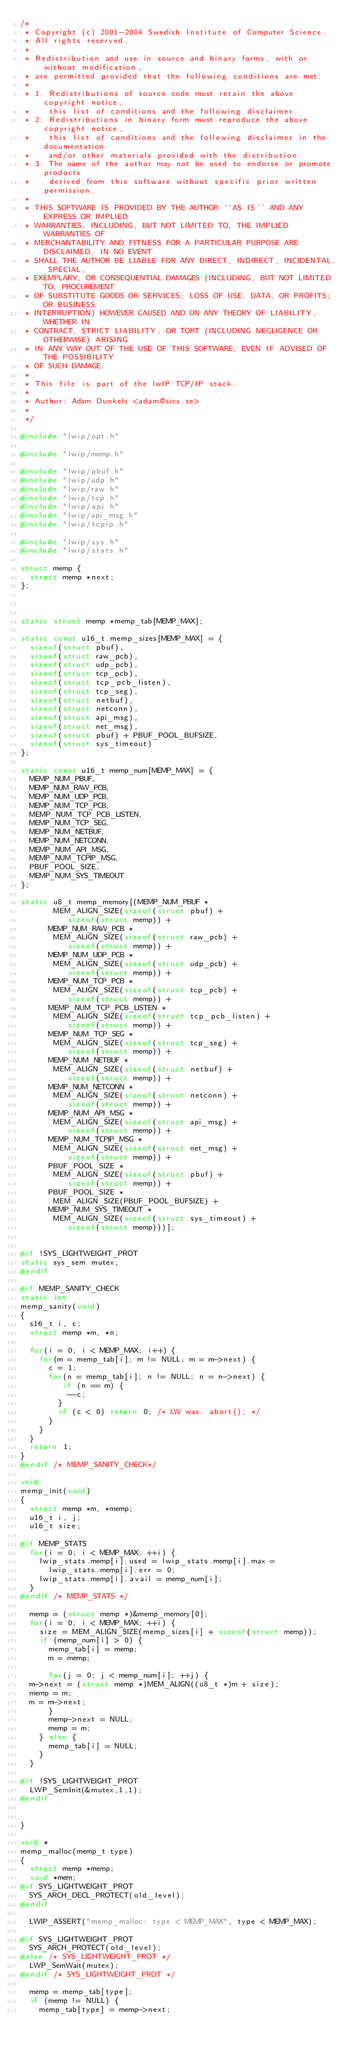Convert code to text. <code><loc_0><loc_0><loc_500><loc_500><_C_>/*
 * Copyright (c) 2001-2004 Swedish Institute of Computer Science.
 * All rights reserved. 
 * 
 * Redistribution and use in source and binary forms, with or without modification, 
 * are permitted provided that the following conditions are met:
 *
 * 1. Redistributions of source code must retain the above copyright notice,
 *    this list of conditions and the following disclaimer.
 * 2. Redistributions in binary form must reproduce the above copyright notice,
 *    this list of conditions and the following disclaimer in the documentation
 *    and/or other materials provided with the distribution.
 * 3. The name of the author may not be used to endorse or promote products
 *    derived from this software without specific prior written permission. 
 *
 * THIS SOFTWARE IS PROVIDED BY THE AUTHOR ``AS IS'' AND ANY EXPRESS OR IMPLIED 
 * WARRANTIES, INCLUDING, BUT NOT LIMITED TO, THE IMPLIED WARRANTIES OF 
 * MERCHANTABILITY AND FITNESS FOR A PARTICULAR PURPOSE ARE DISCLAIMED. IN NO EVENT 
 * SHALL THE AUTHOR BE LIABLE FOR ANY DIRECT, INDIRECT, INCIDENTAL, SPECIAL, 
 * EXEMPLARY, OR CONSEQUENTIAL DAMAGES (INCLUDING, BUT NOT LIMITED TO, PROCUREMENT 
 * OF SUBSTITUTE GOODS OR SERVICES; LOSS OF USE, DATA, OR PROFITS; OR BUSINESS 
 * INTERRUPTION) HOWEVER CAUSED AND ON ANY THEORY OF LIABILITY, WHETHER IN 
 * CONTRACT, STRICT LIABILITY, OR TORT (INCLUDING NEGLIGENCE OR OTHERWISE) ARISING 
 * IN ANY WAY OUT OF THE USE OF THIS SOFTWARE, EVEN IF ADVISED OF THE POSSIBILITY 
 * OF SUCH DAMAGE.
 *
 * This file is part of the lwIP TCP/IP stack.
 * 
 * Author: Adam Dunkels <adam@sics.se>
 *
 */

#include "lwip/opt.h"

#include "lwip/memp.h"

#include "lwip/pbuf.h"
#include "lwip/udp.h"
#include "lwip/raw.h"
#include "lwip/tcp.h"
#include "lwip/api.h"
#include "lwip/api_msg.h"
#include "lwip/tcpip.h"

#include "lwip/sys.h"
#include "lwip/stats.h"

struct memp {
  struct memp *next;
};



static struct memp *memp_tab[MEMP_MAX];

static const u16_t memp_sizes[MEMP_MAX] = {
  sizeof(struct pbuf),
  sizeof(struct raw_pcb),
  sizeof(struct udp_pcb),
  sizeof(struct tcp_pcb),
  sizeof(struct tcp_pcb_listen),
  sizeof(struct tcp_seg),
  sizeof(struct netbuf),
  sizeof(struct netconn),
  sizeof(struct api_msg),
  sizeof(struct net_msg),
  sizeof(struct pbuf) + PBUF_POOL_BUFSIZE,
  sizeof(struct sys_timeout)
};

static const u16_t memp_num[MEMP_MAX] = {
  MEMP_NUM_PBUF,
  MEMP_NUM_RAW_PCB,
  MEMP_NUM_UDP_PCB,
  MEMP_NUM_TCP_PCB,
  MEMP_NUM_TCP_PCB_LISTEN,
  MEMP_NUM_TCP_SEG,
  MEMP_NUM_NETBUF,
  MEMP_NUM_NETCONN,
  MEMP_NUM_API_MSG,
  MEMP_NUM_TCPIP_MSG,
  PBUF_POOL_SIZE,
  MEMP_NUM_SYS_TIMEOUT
};

static u8_t memp_memory[(MEMP_NUM_PBUF *
       MEM_ALIGN_SIZE(sizeof(struct pbuf) +
          sizeof(struct memp)) +
      MEMP_NUM_RAW_PCB *
       MEM_ALIGN_SIZE(sizeof(struct raw_pcb) +
          sizeof(struct memp)) +
      MEMP_NUM_UDP_PCB *
       MEM_ALIGN_SIZE(sizeof(struct udp_pcb) +
          sizeof(struct memp)) +
      MEMP_NUM_TCP_PCB *
       MEM_ALIGN_SIZE(sizeof(struct tcp_pcb) +
          sizeof(struct memp)) +
      MEMP_NUM_TCP_PCB_LISTEN *
       MEM_ALIGN_SIZE(sizeof(struct tcp_pcb_listen) +
          sizeof(struct memp)) +
      MEMP_NUM_TCP_SEG *
       MEM_ALIGN_SIZE(sizeof(struct tcp_seg) +
          sizeof(struct memp)) +
      MEMP_NUM_NETBUF *
       MEM_ALIGN_SIZE(sizeof(struct netbuf) +
          sizeof(struct memp)) +
      MEMP_NUM_NETCONN *
       MEM_ALIGN_SIZE(sizeof(struct netconn) +
          sizeof(struct memp)) +
      MEMP_NUM_API_MSG *
       MEM_ALIGN_SIZE(sizeof(struct api_msg) +
          sizeof(struct memp)) +
      MEMP_NUM_TCPIP_MSG *
       MEM_ALIGN_SIZE(sizeof(struct net_msg) +
          sizeof(struct memp)) +
      PBUF_POOL_SIZE *
       MEM_ALIGN_SIZE(sizeof(struct pbuf) +
          sizeof(struct memp)) +
      PBUF_POOL_SIZE *
       MEM_ALIGN_SIZE(PBUF_POOL_BUFSIZE) +
      MEMP_NUM_SYS_TIMEOUT *
       MEM_ALIGN_SIZE(sizeof(struct sys_timeout) +
          sizeof(struct memp)))];


#if !SYS_LIGHTWEIGHT_PROT
static sys_sem mutex;
#endif

#if MEMP_SANITY_CHECK
static int
memp_sanity(void)
{
  s16_t i, c;
  struct memp *m, *n;

  for(i = 0; i < MEMP_MAX; i++) {
    for(m = memp_tab[i]; m != NULL; m = m->next) {
      c = 1;
      for(n = memp_tab[i]; n != NULL; n = n->next) {
         if (n == m) {
          --c;
        }
        if (c < 0) return 0; /* LW was: abort(); */
      }
    }
  }
  return 1;
}
#endif /* MEMP_SANITY_CHECK*/

void
memp_init(void)
{
  struct memp *m, *memp;
  u16_t i, j;
  u16_t size;
      
#if MEMP_STATS
  for(i = 0; i < MEMP_MAX; ++i) {
    lwip_stats.memp[i].used = lwip_stats.memp[i].max =
      lwip_stats.memp[i].err = 0;
    lwip_stats.memp[i].avail = memp_num[i];
  }
#endif /* MEMP_STATS */

  memp = (struct memp *)&memp_memory[0];
  for(i = 0; i < MEMP_MAX; ++i) {
    size = MEM_ALIGN_SIZE(memp_sizes[i] + sizeof(struct memp));
    if (memp_num[i] > 0) {
      memp_tab[i] = memp;
      m = memp;
      
      for(j = 0; j < memp_num[i]; ++j) {
  m->next = (struct memp *)MEM_ALIGN((u8_t *)m + size);
  memp = m;
  m = m->next;
      }
      memp->next = NULL;
      memp = m;
    } else {
      memp_tab[i] = NULL;
    }
  }

#if !SYS_LIGHTWEIGHT_PROT
  LWP_SemInit(&mutex,1,1);
#endif

  
}

void *
memp_malloc(memp_t type)
{
  struct memp *memp;
  void *mem;
#if SYS_LIGHTWEIGHT_PROT
  SYS_ARCH_DECL_PROTECT(old_level);
#endif
 
  LWIP_ASSERT("memp_malloc: type < MEMP_MAX", type < MEMP_MAX);

#if SYS_LIGHTWEIGHT_PROT
  SYS_ARCH_PROTECT(old_level);
#else /* SYS_LIGHTWEIGHT_PROT */  
  LWP_SemWait(mutex);
#endif /* SYS_LIGHTWEIGHT_PROT */  

  memp = memp_tab[type];
  if (memp != NULL) {    
    memp_tab[type] = memp->next;    </code> 